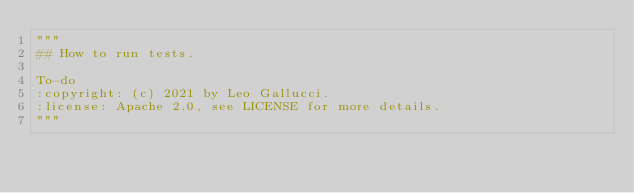Convert code to text. <code><loc_0><loc_0><loc_500><loc_500><_Python_>"""
## How to run tests.

To-do
:copyright: (c) 2021 by Leo Gallucci.
:license: Apache 2.0, see LICENSE for more details.
"""
</code> 